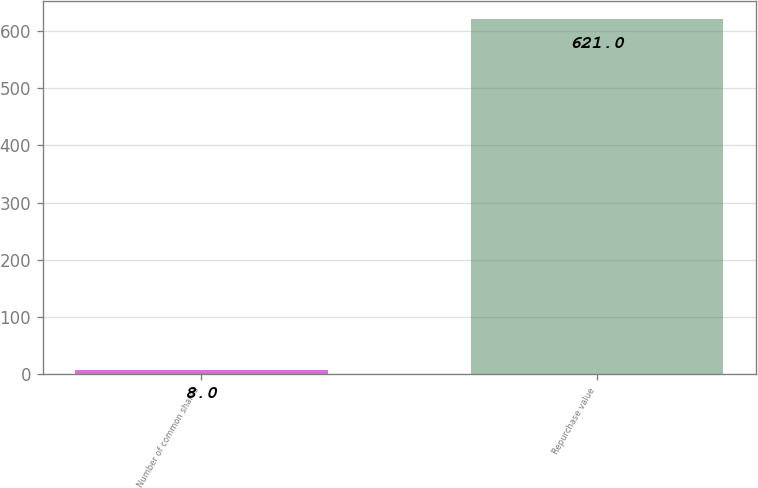Convert chart. <chart><loc_0><loc_0><loc_500><loc_500><bar_chart><fcel>Number of common shares<fcel>Repurchase value<nl><fcel>8<fcel>621<nl></chart> 